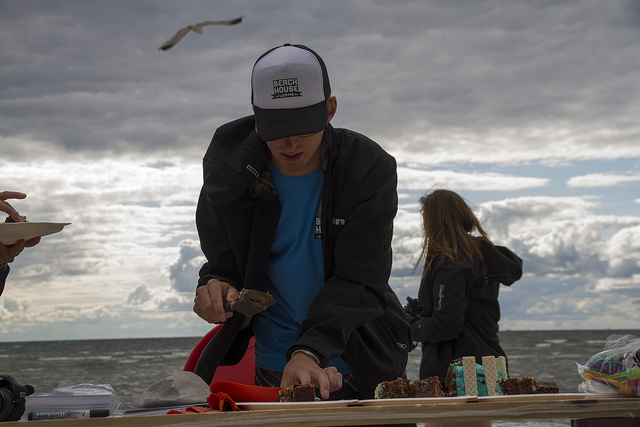How many people are there? There are two people visible in the image. One person appears to be cutting cake or a similar type of food on a table, while another person can be seen in the background, possibly overlooking the water or engaged in an activity near the beach. 